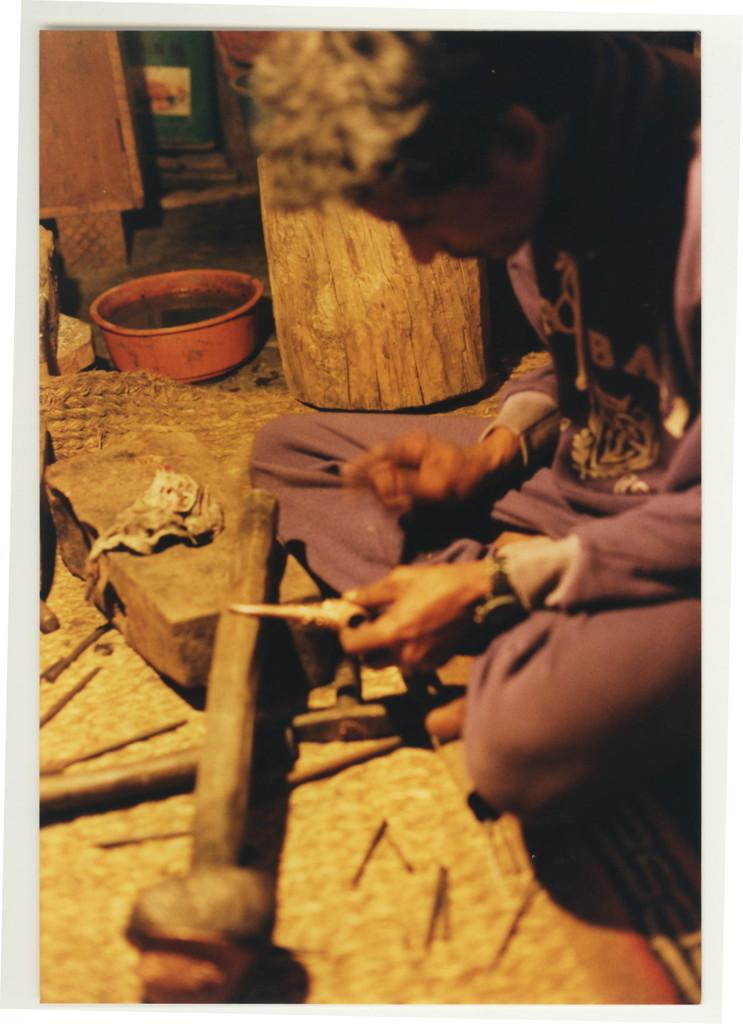What is the person in the image doing? The person is sitting on the ground in the image. What is located near the person? There is a bowl and a wooden log in the image. What type of objects are used for striking or shaping in the image? Hammers are visible in the image. What other items are present in the image that can be used for various tasks? Tools are present in the image. Can you describe any other objects in the image that were not specified? There are other unspecified objects in the image. What type of humor can be seen in the image? There is no humor present in the image; it is a scene with a person sitting on the ground, a bowl, a wooden log, hammers, tools, and other unspecified objects. Can you describe the crow that is perched on the person's shoulder in the image? There is no crow present in the image. 